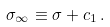<formula> <loc_0><loc_0><loc_500><loc_500>\sigma _ { \infty } \equiv \sigma + c _ { 1 } \, .</formula> 